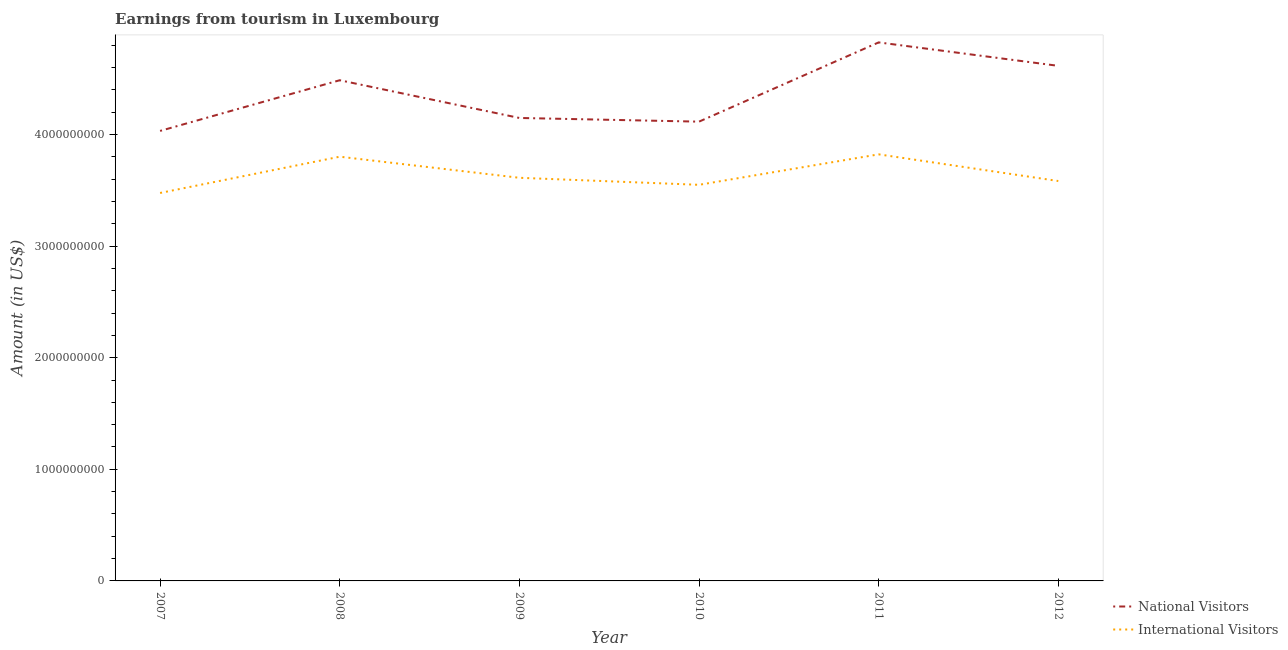Does the line corresponding to amount earned from national visitors intersect with the line corresponding to amount earned from international visitors?
Ensure brevity in your answer.  No. Is the number of lines equal to the number of legend labels?
Give a very brief answer. Yes. What is the amount earned from international visitors in 2012?
Give a very brief answer. 3.58e+09. Across all years, what is the maximum amount earned from national visitors?
Provide a short and direct response. 4.82e+09. Across all years, what is the minimum amount earned from national visitors?
Your response must be concise. 4.03e+09. In which year was the amount earned from national visitors minimum?
Keep it short and to the point. 2007. What is the total amount earned from international visitors in the graph?
Provide a short and direct response. 2.18e+1. What is the difference between the amount earned from international visitors in 2008 and that in 2009?
Offer a very short reply. 1.89e+08. What is the difference between the amount earned from national visitors in 2011 and the amount earned from international visitors in 2009?
Your answer should be compact. 1.21e+09. What is the average amount earned from national visitors per year?
Offer a terse response. 4.37e+09. In the year 2009, what is the difference between the amount earned from international visitors and amount earned from national visitors?
Ensure brevity in your answer.  -5.36e+08. What is the ratio of the amount earned from international visitors in 2011 to that in 2012?
Make the answer very short. 1.07. What is the difference between the highest and the second highest amount earned from national visitors?
Your answer should be compact. 2.10e+08. What is the difference between the highest and the lowest amount earned from national visitors?
Offer a very short reply. 7.93e+08. Does the amount earned from international visitors monotonically increase over the years?
Your answer should be compact. No. Is the amount earned from international visitors strictly less than the amount earned from national visitors over the years?
Your answer should be compact. Yes. How many lines are there?
Provide a succinct answer. 2. Does the graph contain any zero values?
Give a very brief answer. No. How many legend labels are there?
Your answer should be very brief. 2. How are the legend labels stacked?
Ensure brevity in your answer.  Vertical. What is the title of the graph?
Give a very brief answer. Earnings from tourism in Luxembourg. Does "Death rate" appear as one of the legend labels in the graph?
Offer a terse response. No. What is the label or title of the X-axis?
Your answer should be very brief. Year. What is the Amount (in US$) of National Visitors in 2007?
Your response must be concise. 4.03e+09. What is the Amount (in US$) in International Visitors in 2007?
Make the answer very short. 3.48e+09. What is the Amount (in US$) in National Visitors in 2008?
Your answer should be compact. 4.49e+09. What is the Amount (in US$) in International Visitors in 2008?
Give a very brief answer. 3.80e+09. What is the Amount (in US$) of National Visitors in 2009?
Make the answer very short. 4.15e+09. What is the Amount (in US$) of International Visitors in 2009?
Offer a terse response. 3.61e+09. What is the Amount (in US$) in National Visitors in 2010?
Provide a succinct answer. 4.12e+09. What is the Amount (in US$) in International Visitors in 2010?
Your response must be concise. 3.55e+09. What is the Amount (in US$) of National Visitors in 2011?
Your answer should be very brief. 4.82e+09. What is the Amount (in US$) of International Visitors in 2011?
Ensure brevity in your answer.  3.82e+09. What is the Amount (in US$) of National Visitors in 2012?
Make the answer very short. 4.62e+09. What is the Amount (in US$) of International Visitors in 2012?
Ensure brevity in your answer.  3.58e+09. Across all years, what is the maximum Amount (in US$) of National Visitors?
Your answer should be compact. 4.82e+09. Across all years, what is the maximum Amount (in US$) in International Visitors?
Keep it short and to the point. 3.82e+09. Across all years, what is the minimum Amount (in US$) of National Visitors?
Offer a very short reply. 4.03e+09. Across all years, what is the minimum Amount (in US$) in International Visitors?
Give a very brief answer. 3.48e+09. What is the total Amount (in US$) of National Visitors in the graph?
Keep it short and to the point. 2.62e+1. What is the total Amount (in US$) of International Visitors in the graph?
Your answer should be compact. 2.18e+1. What is the difference between the Amount (in US$) of National Visitors in 2007 and that in 2008?
Offer a very short reply. -4.54e+08. What is the difference between the Amount (in US$) of International Visitors in 2007 and that in 2008?
Your answer should be compact. -3.25e+08. What is the difference between the Amount (in US$) in National Visitors in 2007 and that in 2009?
Provide a short and direct response. -1.16e+08. What is the difference between the Amount (in US$) in International Visitors in 2007 and that in 2009?
Provide a succinct answer. -1.36e+08. What is the difference between the Amount (in US$) of National Visitors in 2007 and that in 2010?
Offer a terse response. -8.30e+07. What is the difference between the Amount (in US$) of International Visitors in 2007 and that in 2010?
Provide a short and direct response. -7.30e+07. What is the difference between the Amount (in US$) of National Visitors in 2007 and that in 2011?
Make the answer very short. -7.93e+08. What is the difference between the Amount (in US$) in International Visitors in 2007 and that in 2011?
Make the answer very short. -3.46e+08. What is the difference between the Amount (in US$) of National Visitors in 2007 and that in 2012?
Offer a terse response. -5.83e+08. What is the difference between the Amount (in US$) in International Visitors in 2007 and that in 2012?
Your answer should be compact. -1.07e+08. What is the difference between the Amount (in US$) of National Visitors in 2008 and that in 2009?
Your response must be concise. 3.38e+08. What is the difference between the Amount (in US$) in International Visitors in 2008 and that in 2009?
Your answer should be compact. 1.89e+08. What is the difference between the Amount (in US$) in National Visitors in 2008 and that in 2010?
Provide a short and direct response. 3.71e+08. What is the difference between the Amount (in US$) of International Visitors in 2008 and that in 2010?
Make the answer very short. 2.52e+08. What is the difference between the Amount (in US$) in National Visitors in 2008 and that in 2011?
Offer a terse response. -3.39e+08. What is the difference between the Amount (in US$) in International Visitors in 2008 and that in 2011?
Keep it short and to the point. -2.10e+07. What is the difference between the Amount (in US$) of National Visitors in 2008 and that in 2012?
Keep it short and to the point. -1.29e+08. What is the difference between the Amount (in US$) of International Visitors in 2008 and that in 2012?
Offer a terse response. 2.18e+08. What is the difference between the Amount (in US$) in National Visitors in 2009 and that in 2010?
Your answer should be very brief. 3.30e+07. What is the difference between the Amount (in US$) of International Visitors in 2009 and that in 2010?
Ensure brevity in your answer.  6.30e+07. What is the difference between the Amount (in US$) in National Visitors in 2009 and that in 2011?
Provide a short and direct response. -6.77e+08. What is the difference between the Amount (in US$) in International Visitors in 2009 and that in 2011?
Your answer should be very brief. -2.10e+08. What is the difference between the Amount (in US$) of National Visitors in 2009 and that in 2012?
Provide a succinct answer. -4.67e+08. What is the difference between the Amount (in US$) of International Visitors in 2009 and that in 2012?
Keep it short and to the point. 2.90e+07. What is the difference between the Amount (in US$) in National Visitors in 2010 and that in 2011?
Your response must be concise. -7.10e+08. What is the difference between the Amount (in US$) in International Visitors in 2010 and that in 2011?
Your response must be concise. -2.73e+08. What is the difference between the Amount (in US$) of National Visitors in 2010 and that in 2012?
Offer a very short reply. -5.00e+08. What is the difference between the Amount (in US$) of International Visitors in 2010 and that in 2012?
Provide a succinct answer. -3.40e+07. What is the difference between the Amount (in US$) of National Visitors in 2011 and that in 2012?
Ensure brevity in your answer.  2.10e+08. What is the difference between the Amount (in US$) in International Visitors in 2011 and that in 2012?
Your response must be concise. 2.39e+08. What is the difference between the Amount (in US$) of National Visitors in 2007 and the Amount (in US$) of International Visitors in 2008?
Offer a terse response. 2.31e+08. What is the difference between the Amount (in US$) in National Visitors in 2007 and the Amount (in US$) in International Visitors in 2009?
Your answer should be very brief. 4.20e+08. What is the difference between the Amount (in US$) in National Visitors in 2007 and the Amount (in US$) in International Visitors in 2010?
Your answer should be very brief. 4.83e+08. What is the difference between the Amount (in US$) in National Visitors in 2007 and the Amount (in US$) in International Visitors in 2011?
Your answer should be very brief. 2.10e+08. What is the difference between the Amount (in US$) in National Visitors in 2007 and the Amount (in US$) in International Visitors in 2012?
Your response must be concise. 4.49e+08. What is the difference between the Amount (in US$) in National Visitors in 2008 and the Amount (in US$) in International Visitors in 2009?
Keep it short and to the point. 8.74e+08. What is the difference between the Amount (in US$) in National Visitors in 2008 and the Amount (in US$) in International Visitors in 2010?
Provide a short and direct response. 9.37e+08. What is the difference between the Amount (in US$) of National Visitors in 2008 and the Amount (in US$) of International Visitors in 2011?
Ensure brevity in your answer.  6.64e+08. What is the difference between the Amount (in US$) of National Visitors in 2008 and the Amount (in US$) of International Visitors in 2012?
Provide a short and direct response. 9.03e+08. What is the difference between the Amount (in US$) of National Visitors in 2009 and the Amount (in US$) of International Visitors in 2010?
Ensure brevity in your answer.  5.99e+08. What is the difference between the Amount (in US$) of National Visitors in 2009 and the Amount (in US$) of International Visitors in 2011?
Give a very brief answer. 3.26e+08. What is the difference between the Amount (in US$) in National Visitors in 2009 and the Amount (in US$) in International Visitors in 2012?
Provide a succinct answer. 5.65e+08. What is the difference between the Amount (in US$) of National Visitors in 2010 and the Amount (in US$) of International Visitors in 2011?
Your answer should be very brief. 2.93e+08. What is the difference between the Amount (in US$) in National Visitors in 2010 and the Amount (in US$) in International Visitors in 2012?
Give a very brief answer. 5.32e+08. What is the difference between the Amount (in US$) of National Visitors in 2011 and the Amount (in US$) of International Visitors in 2012?
Ensure brevity in your answer.  1.24e+09. What is the average Amount (in US$) of National Visitors per year?
Give a very brief answer. 4.37e+09. What is the average Amount (in US$) in International Visitors per year?
Ensure brevity in your answer.  3.64e+09. In the year 2007, what is the difference between the Amount (in US$) in National Visitors and Amount (in US$) in International Visitors?
Offer a very short reply. 5.56e+08. In the year 2008, what is the difference between the Amount (in US$) of National Visitors and Amount (in US$) of International Visitors?
Make the answer very short. 6.85e+08. In the year 2009, what is the difference between the Amount (in US$) in National Visitors and Amount (in US$) in International Visitors?
Your answer should be very brief. 5.36e+08. In the year 2010, what is the difference between the Amount (in US$) of National Visitors and Amount (in US$) of International Visitors?
Offer a terse response. 5.66e+08. In the year 2011, what is the difference between the Amount (in US$) of National Visitors and Amount (in US$) of International Visitors?
Provide a succinct answer. 1.00e+09. In the year 2012, what is the difference between the Amount (in US$) in National Visitors and Amount (in US$) in International Visitors?
Give a very brief answer. 1.03e+09. What is the ratio of the Amount (in US$) of National Visitors in 2007 to that in 2008?
Give a very brief answer. 0.9. What is the ratio of the Amount (in US$) in International Visitors in 2007 to that in 2008?
Your response must be concise. 0.91. What is the ratio of the Amount (in US$) in National Visitors in 2007 to that in 2009?
Offer a very short reply. 0.97. What is the ratio of the Amount (in US$) of International Visitors in 2007 to that in 2009?
Keep it short and to the point. 0.96. What is the ratio of the Amount (in US$) in National Visitors in 2007 to that in 2010?
Your response must be concise. 0.98. What is the ratio of the Amount (in US$) of International Visitors in 2007 to that in 2010?
Your answer should be compact. 0.98. What is the ratio of the Amount (in US$) of National Visitors in 2007 to that in 2011?
Your answer should be compact. 0.84. What is the ratio of the Amount (in US$) in International Visitors in 2007 to that in 2011?
Give a very brief answer. 0.91. What is the ratio of the Amount (in US$) in National Visitors in 2007 to that in 2012?
Provide a succinct answer. 0.87. What is the ratio of the Amount (in US$) in International Visitors in 2007 to that in 2012?
Provide a succinct answer. 0.97. What is the ratio of the Amount (in US$) of National Visitors in 2008 to that in 2009?
Offer a terse response. 1.08. What is the ratio of the Amount (in US$) of International Visitors in 2008 to that in 2009?
Your answer should be compact. 1.05. What is the ratio of the Amount (in US$) in National Visitors in 2008 to that in 2010?
Make the answer very short. 1.09. What is the ratio of the Amount (in US$) in International Visitors in 2008 to that in 2010?
Keep it short and to the point. 1.07. What is the ratio of the Amount (in US$) of National Visitors in 2008 to that in 2011?
Your response must be concise. 0.93. What is the ratio of the Amount (in US$) in National Visitors in 2008 to that in 2012?
Your response must be concise. 0.97. What is the ratio of the Amount (in US$) in International Visitors in 2008 to that in 2012?
Offer a very short reply. 1.06. What is the ratio of the Amount (in US$) of National Visitors in 2009 to that in 2010?
Provide a short and direct response. 1.01. What is the ratio of the Amount (in US$) in International Visitors in 2009 to that in 2010?
Offer a terse response. 1.02. What is the ratio of the Amount (in US$) of National Visitors in 2009 to that in 2011?
Keep it short and to the point. 0.86. What is the ratio of the Amount (in US$) of International Visitors in 2009 to that in 2011?
Your response must be concise. 0.95. What is the ratio of the Amount (in US$) of National Visitors in 2009 to that in 2012?
Ensure brevity in your answer.  0.9. What is the ratio of the Amount (in US$) of International Visitors in 2009 to that in 2012?
Offer a very short reply. 1.01. What is the ratio of the Amount (in US$) of National Visitors in 2010 to that in 2011?
Ensure brevity in your answer.  0.85. What is the ratio of the Amount (in US$) of National Visitors in 2010 to that in 2012?
Give a very brief answer. 0.89. What is the ratio of the Amount (in US$) of International Visitors in 2010 to that in 2012?
Offer a terse response. 0.99. What is the ratio of the Amount (in US$) in National Visitors in 2011 to that in 2012?
Keep it short and to the point. 1.05. What is the ratio of the Amount (in US$) in International Visitors in 2011 to that in 2012?
Your answer should be very brief. 1.07. What is the difference between the highest and the second highest Amount (in US$) in National Visitors?
Your response must be concise. 2.10e+08. What is the difference between the highest and the second highest Amount (in US$) of International Visitors?
Your answer should be very brief. 2.10e+07. What is the difference between the highest and the lowest Amount (in US$) in National Visitors?
Offer a terse response. 7.93e+08. What is the difference between the highest and the lowest Amount (in US$) in International Visitors?
Your answer should be compact. 3.46e+08. 